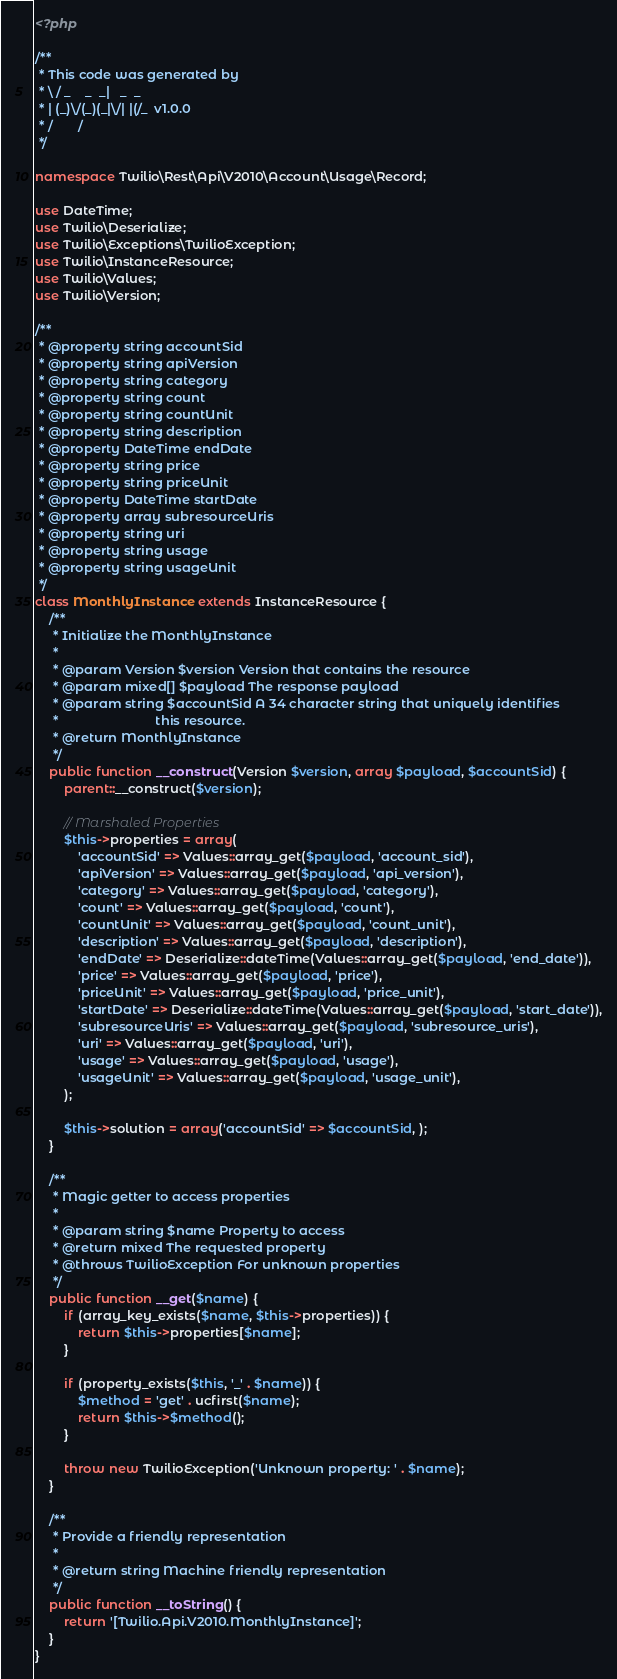<code> <loc_0><loc_0><loc_500><loc_500><_PHP_><?php

/**
 * This code was generated by
 * \ / _    _  _|   _  _
 * | (_)\/(_)(_|\/| |(/_  v1.0.0
 * /       /
 */

namespace Twilio\Rest\Api\V2010\Account\Usage\Record;

use DateTime;
use Twilio\Deserialize;
use Twilio\Exceptions\TwilioException;
use Twilio\InstanceResource;
use Twilio\Values;
use Twilio\Version;

/**
 * @property string accountSid
 * @property string apiVersion
 * @property string category
 * @property string count
 * @property string countUnit
 * @property string description
 * @property DateTime endDate
 * @property string price
 * @property string priceUnit
 * @property DateTime startDate
 * @property array subresourceUris
 * @property string uri
 * @property string usage
 * @property string usageUnit
 */
class MonthlyInstance extends InstanceResource {
    /**
     * Initialize the MonthlyInstance
     * 
     * @param Version $version Version that contains the resource
     * @param mixed[] $payload The response payload
     * @param string $accountSid A 34 character string that uniquely identifies
     *                           this resource.
     * @return MonthlyInstance
     */
    public function __construct(Version $version, array $payload, $accountSid) {
        parent::__construct($version);

        // Marshaled Properties
        $this->properties = array(
            'accountSid' => Values::array_get($payload, 'account_sid'),
            'apiVersion' => Values::array_get($payload, 'api_version'),
            'category' => Values::array_get($payload, 'category'),
            'count' => Values::array_get($payload, 'count'),
            'countUnit' => Values::array_get($payload, 'count_unit'),
            'description' => Values::array_get($payload, 'description'),
            'endDate' => Deserialize::dateTime(Values::array_get($payload, 'end_date')),
            'price' => Values::array_get($payload, 'price'),
            'priceUnit' => Values::array_get($payload, 'price_unit'),
            'startDate' => Deserialize::dateTime(Values::array_get($payload, 'start_date')),
            'subresourceUris' => Values::array_get($payload, 'subresource_uris'),
            'uri' => Values::array_get($payload, 'uri'),
            'usage' => Values::array_get($payload, 'usage'),
            'usageUnit' => Values::array_get($payload, 'usage_unit'),
        );

        $this->solution = array('accountSid' => $accountSid, );
    }

    /**
     * Magic getter to access properties
     * 
     * @param string $name Property to access
     * @return mixed The requested property
     * @throws TwilioException For unknown properties
     */
    public function __get($name) {
        if (array_key_exists($name, $this->properties)) {
            return $this->properties[$name];
        }

        if (property_exists($this, '_' . $name)) {
            $method = 'get' . ucfirst($name);
            return $this->$method();
        }

        throw new TwilioException('Unknown property: ' . $name);
    }

    /**
     * Provide a friendly representation
     * 
     * @return string Machine friendly representation
     */
    public function __toString() {
        return '[Twilio.Api.V2010.MonthlyInstance]';
    }
}</code> 